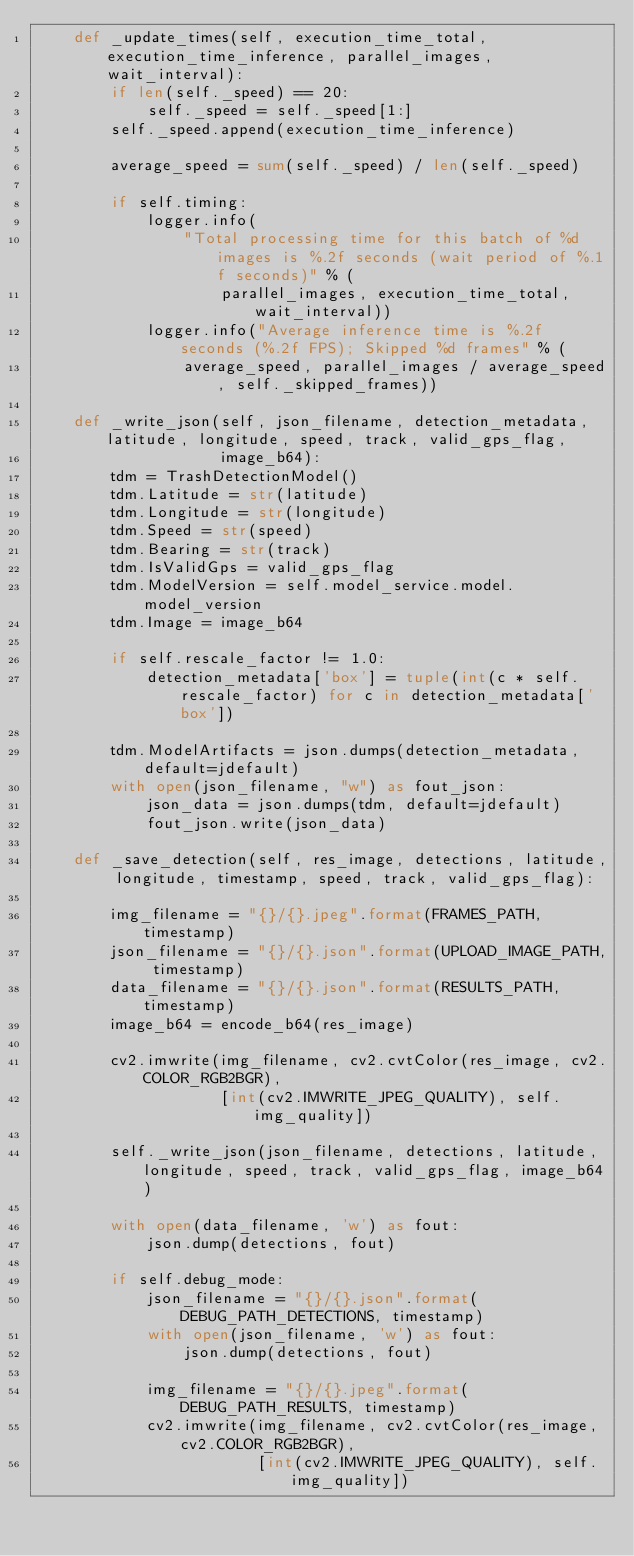Convert code to text. <code><loc_0><loc_0><loc_500><loc_500><_Python_>    def _update_times(self, execution_time_total, execution_time_inference, parallel_images, wait_interval):
        if len(self._speed) == 20:
            self._speed = self._speed[1:]
        self._speed.append(execution_time_inference)

        average_speed = sum(self._speed) / len(self._speed)

        if self.timing:
            logger.info(
                "Total processing time for this batch of %d images is %.2f seconds (wait period of %.1f seconds)" % (
                    parallel_images, execution_time_total, wait_interval))
            logger.info("Average inference time is %.2f seconds (%.2f FPS); Skipped %d frames" % (
                average_speed, parallel_images / average_speed, self._skipped_frames))

    def _write_json(self, json_filename, detection_metadata, latitude, longitude, speed, track, valid_gps_flag,
                    image_b64):
        tdm = TrashDetectionModel()
        tdm.Latitude = str(latitude)
        tdm.Longitude = str(longitude)
        tdm.Speed = str(speed)
        tdm.Bearing = str(track)
        tdm.IsValidGps = valid_gps_flag
        tdm.ModelVersion = self.model_service.model.model_version
        tdm.Image = image_b64

        if self.rescale_factor != 1.0:
            detection_metadata['box'] = tuple(int(c * self.rescale_factor) for c in detection_metadata['box'])

        tdm.ModelArtifacts = json.dumps(detection_metadata, default=jdefault)
        with open(json_filename, "w") as fout_json:
            json_data = json.dumps(tdm, default=jdefault)
            fout_json.write(json_data)

    def _save_detection(self, res_image, detections, latitude, longitude, timestamp, speed, track, valid_gps_flag):

        img_filename = "{}/{}.jpeg".format(FRAMES_PATH, timestamp)
        json_filename = "{}/{}.json".format(UPLOAD_IMAGE_PATH, timestamp)
        data_filename = "{}/{}.json".format(RESULTS_PATH, timestamp)
        image_b64 = encode_b64(res_image)

        cv2.imwrite(img_filename, cv2.cvtColor(res_image, cv2.COLOR_RGB2BGR),
                    [int(cv2.IMWRITE_JPEG_QUALITY), self.img_quality])

        self._write_json(json_filename, detections, latitude, longitude, speed, track, valid_gps_flag, image_b64)

        with open(data_filename, 'w') as fout:
            json.dump(detections, fout)

        if self.debug_mode:
            json_filename = "{}/{}.json".format(DEBUG_PATH_DETECTIONS, timestamp)
            with open(json_filename, 'w') as fout:
                json.dump(detections, fout)

            img_filename = "{}/{}.jpeg".format(DEBUG_PATH_RESULTS, timestamp)
            cv2.imwrite(img_filename, cv2.cvtColor(res_image, cv2.COLOR_RGB2BGR),
                        [int(cv2.IMWRITE_JPEG_QUALITY), self.img_quality])
</code> 